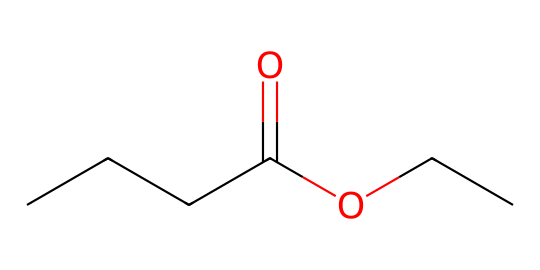What is the name of this ester? The chemical structure consists of a butyric acid moiety (CCCC(=O)O) and an ethyl component (CC), which together form ethyl butyrate.
Answer: ethyl butyrate How many carbon atoms are in this structure? By counting the carbon atoms in the butyric acid part (4 carbon atoms) and the ethyl part (2 carbon atoms), we find a total of 6 carbon atoms.
Answer: 6 What type of functional group is present in this molecule? The molecule contains a carbonyl group (C=O) and an alkoxy group (OCC), characteristic of esters, which results in it being classified as an ester.
Answer: ester What is the melting point of ethyl butyrate? Ethyl butyrate has a melting point of approximately -50 degrees Celsius, which is typical for esters that tend to be low in melting point.
Answer: -50 degrees Celsius How many hydrogen atoms are in this molecule? The molecule has a total of 12 hydrogen atoms, calculated by considering the hydrogen atoms attached to each carbon in accordance with valency rules for carbon.
Answer: 12 What is the primary odor associated with ethyl butyrate? Ethyl butyrate is known for its fruity aroma, often described as reminiscent of pineapple or apple, which is common among esters.
Answer: fruity 